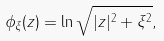Convert formula to latex. <formula><loc_0><loc_0><loc_500><loc_500>\phi _ { \xi } ( z ) = \ln \sqrt { | z | ^ { 2 } + \xi ^ { 2 } } ,</formula> 